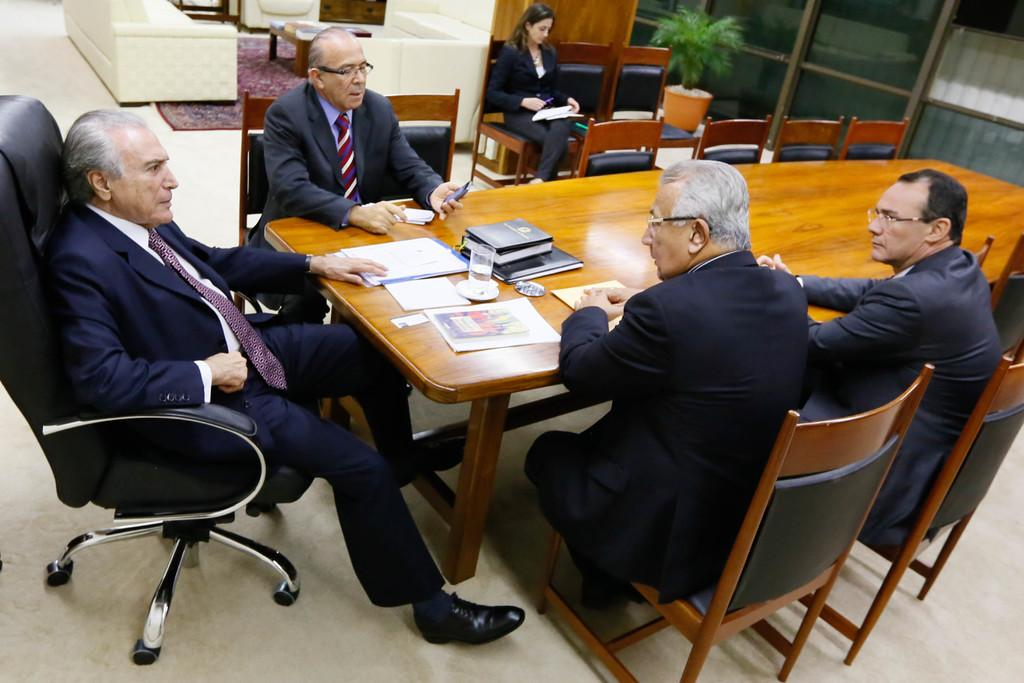How many people are in the image? There is a group of people in the image. What are the people doing in the image? The people are sitting on chairs. Can you describe the person holding a mobile? One person is holding a mobile in the image. What is present on the table in the image? There is a table in the image, and a glass is visible on it. What else can be seen on the table? There are books on the table in the image. What type of plant is present in the image? There is a house plant in the image. What type of steel is used to make the chairs in the image? There is no mention of steel in the image, and the chairs' material is not specified. 